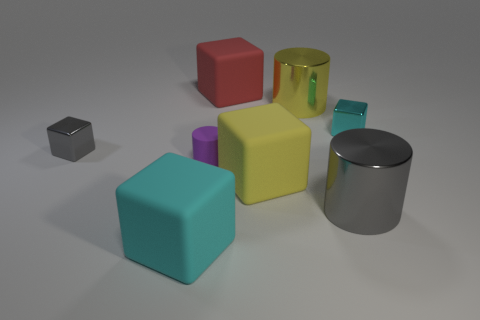Add 2 red metallic balls. How many objects exist? 10 Subtract all purple rubber cylinders. How many cylinders are left? 2 Subtract all gray cylinders. How many cyan blocks are left? 2 Subtract 0 green cylinders. How many objects are left? 8 Subtract all cubes. How many objects are left? 3 Subtract 4 blocks. How many blocks are left? 1 Subtract all cyan cylinders. Subtract all blue spheres. How many cylinders are left? 3 Subtract all blocks. Subtract all large yellow cylinders. How many objects are left? 2 Add 6 tiny purple matte cylinders. How many tiny purple matte cylinders are left? 7 Add 6 large shiny cylinders. How many large shiny cylinders exist? 8 